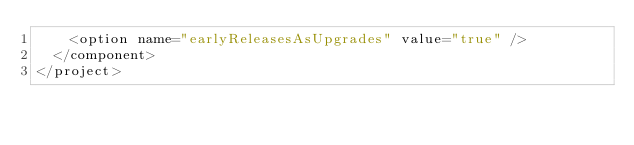<code> <loc_0><loc_0><loc_500><loc_500><_XML_>    <option name="earlyReleasesAsUpgrades" value="true" />
  </component>
</project></code> 